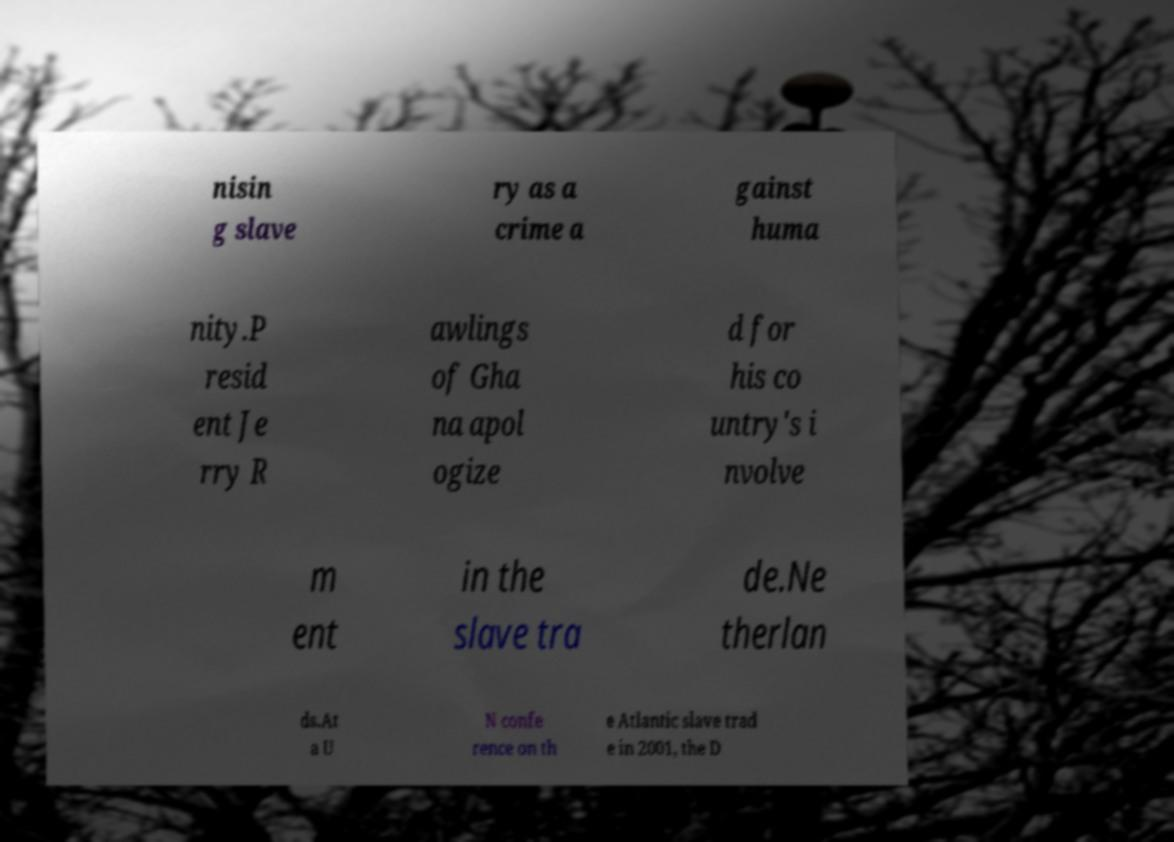Can you accurately transcribe the text from the provided image for me? nisin g slave ry as a crime a gainst huma nity.P resid ent Je rry R awlings of Gha na apol ogize d for his co untry's i nvolve m ent in the slave tra de.Ne therlan ds.At a U N confe rence on th e Atlantic slave trad e in 2001, the D 